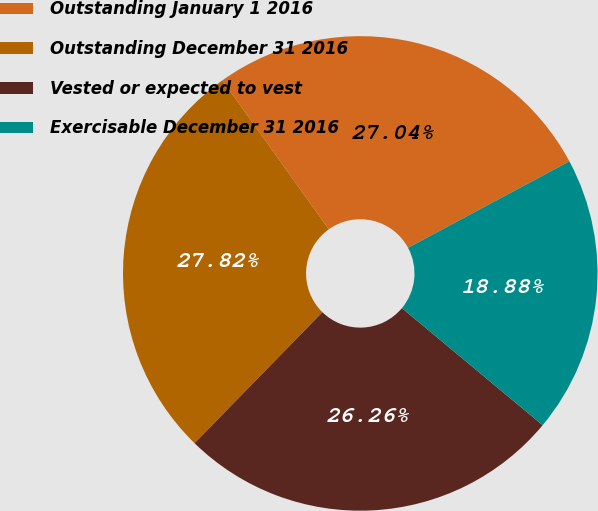Convert chart to OTSL. <chart><loc_0><loc_0><loc_500><loc_500><pie_chart><fcel>Outstanding January 1 2016<fcel>Outstanding December 31 2016<fcel>Vested or expected to vest<fcel>Exercisable December 31 2016<nl><fcel>27.04%<fcel>27.82%<fcel>26.26%<fcel>18.88%<nl></chart> 